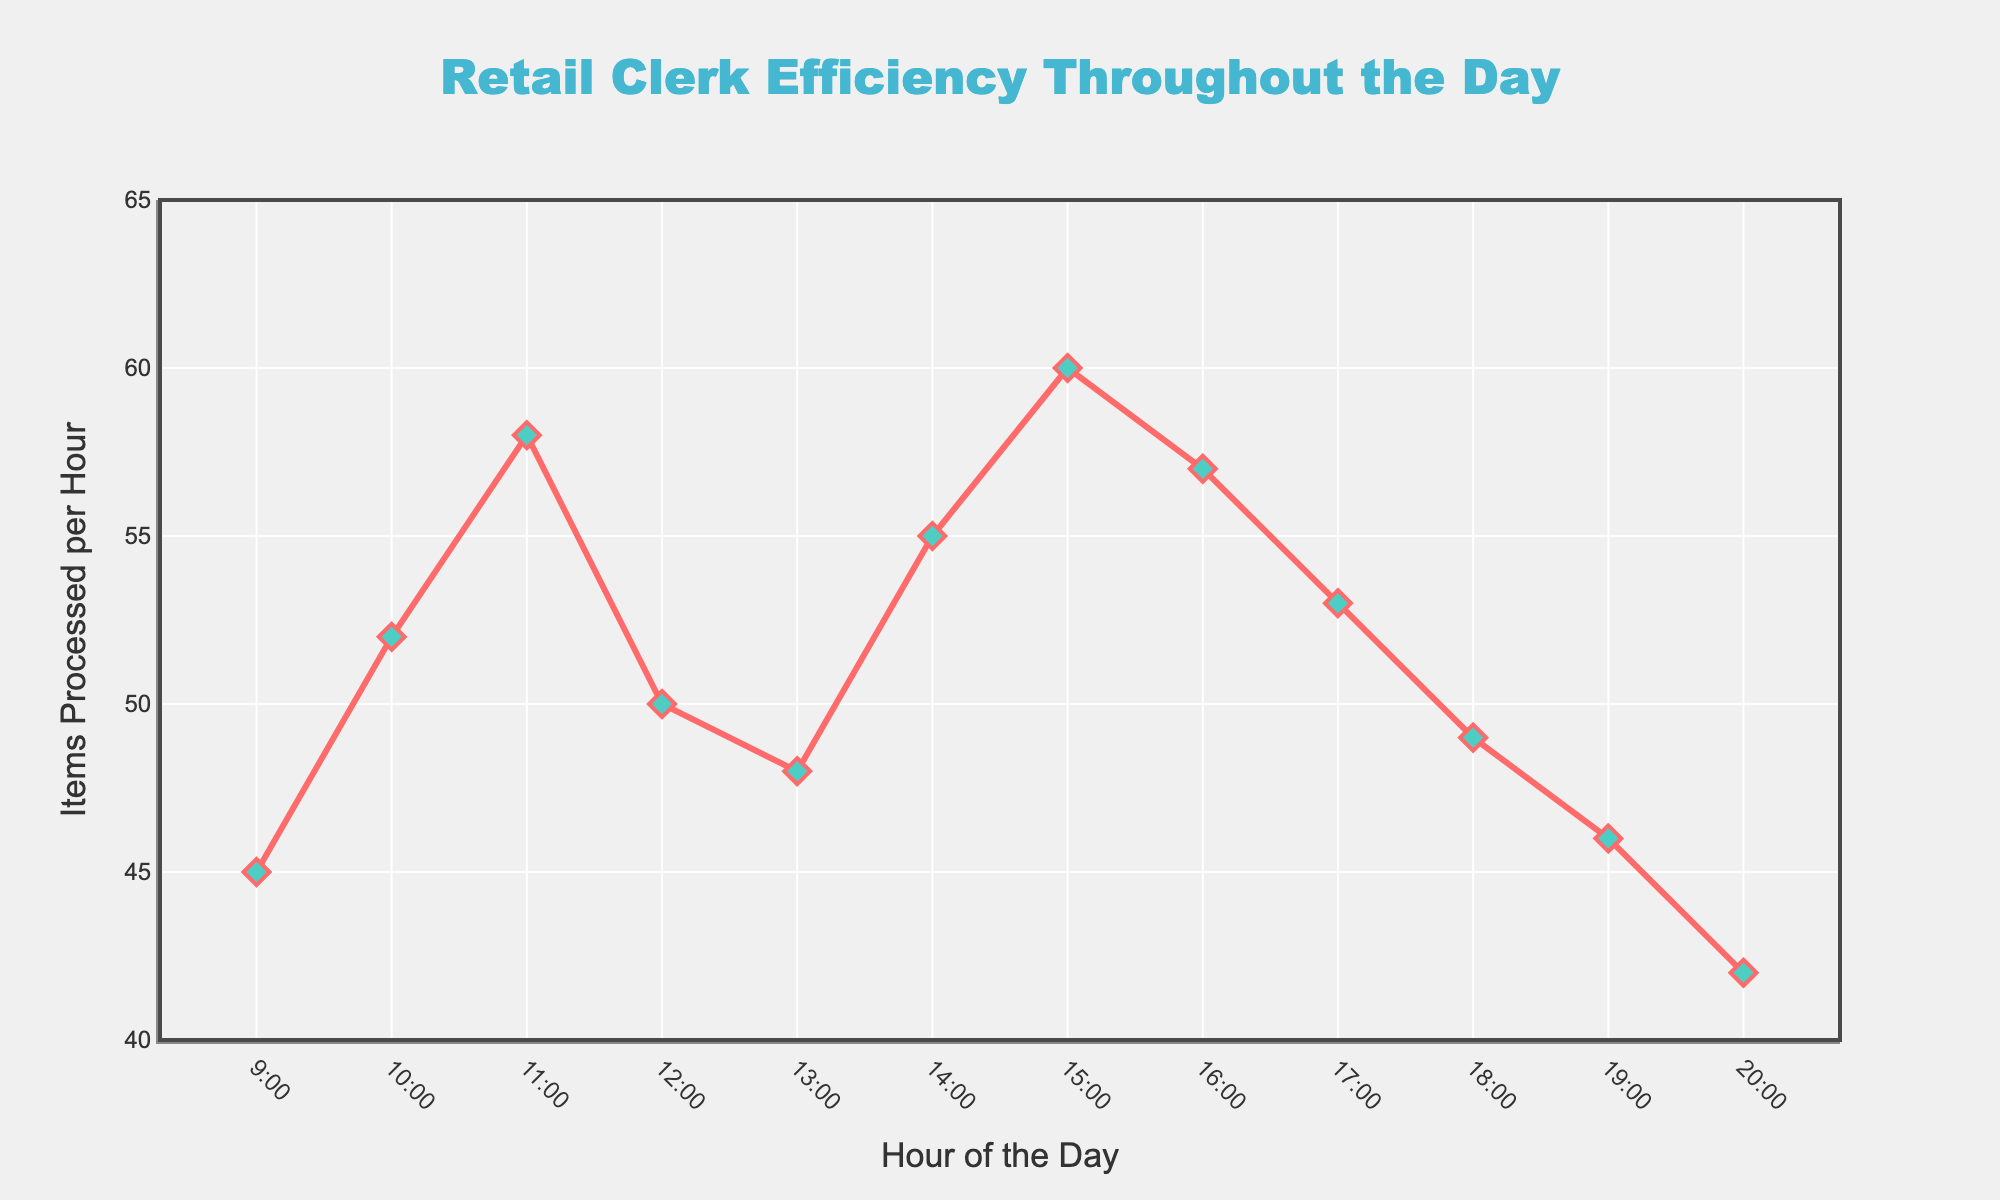What's the peak hour for items processed? To find the peak hour, look for the hour with the highest number of items processed on the y-axis. The point at 15:00 shows the maximum value of 60 items.
Answer: 15:00 How many items are processed in total during the first three hours? The data for the first three hours are 45, 52, and 58 items. Summing them gives 45 + 52 + 58 = 155 items.
Answer: 155 Which hour shows the largest drop in items processed compared to the previous hour? Compare the difference between consecutive hours. The largest drop is from 15:00 to 16:00, where the items processed drop from 60 to 57, showing a decrease of 3 items.
Answer: 15:00 to 16:00 What is the average number of items processed per hour between 12:00 and 16:00? The data for 12:00 to 16:00 are 50, 48, 55, 60, and 57 items. Summing these gives 270, and averaging them gives 270/5 = 54 items per hour.
Answer: 54 Which two hours have the closest number of items processed? By comparing, 17:00 and 18:00 both have processed items close to 53 and 49 respectively. The difference is 4 items.
Answer: 17:00 and 18:00 What is the trend in items processed from 18:00 to 20:00? Observing the values at 18:00, 19:00, and 20:00, the number of items processed decreases progressively from 49 to 46 to 42.
Answer: Decreasing During which hours does the efficiency (items processed) generally increase? The items processed increases from 9:00 to 11:00 (45 to 58), from 13:00 to 15:00 (48 to 60).
Answer: 9:00 to 11:00 and 13:00 to 15:00 Is the pattern of items processed more volatile in the morning or the afternoon? Comparing the morning (9:00 to 12:00) data and the afternoon (13:00 to 18:00) data, morning values 45 to 58 vs. afternoon values 48 to 60 then downward, morning has significant volatility.
Answer: Morning What difference in items processed is seen between 10:00 and 20:00? Items processed at 10:00 is 52 and at 20:00 is 42. The difference is 52 - 42 = 10 items.
Answer: 10 